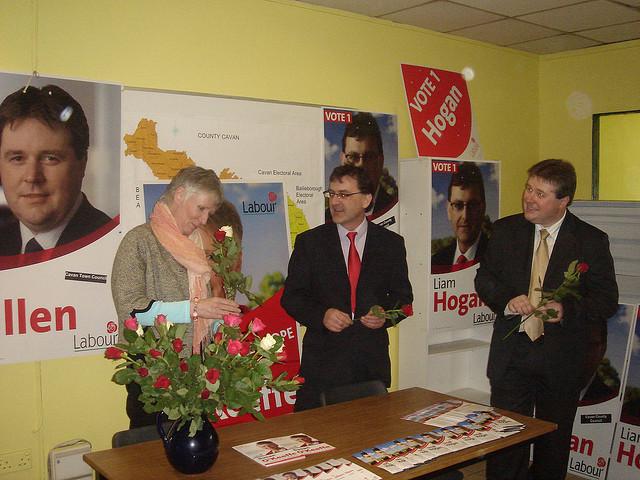Who should we vote for?
Be succinct. Hogan. Are the men wearing ties?
Answer briefly. Yes. What is everyone wearing around their neck?
Be succinct. Tie. Are the flowers artificial?
Give a very brief answer. No. What did the guy bring?
Concise answer only. Flowers. Is there flowers here?
Quick response, please. Yes. 